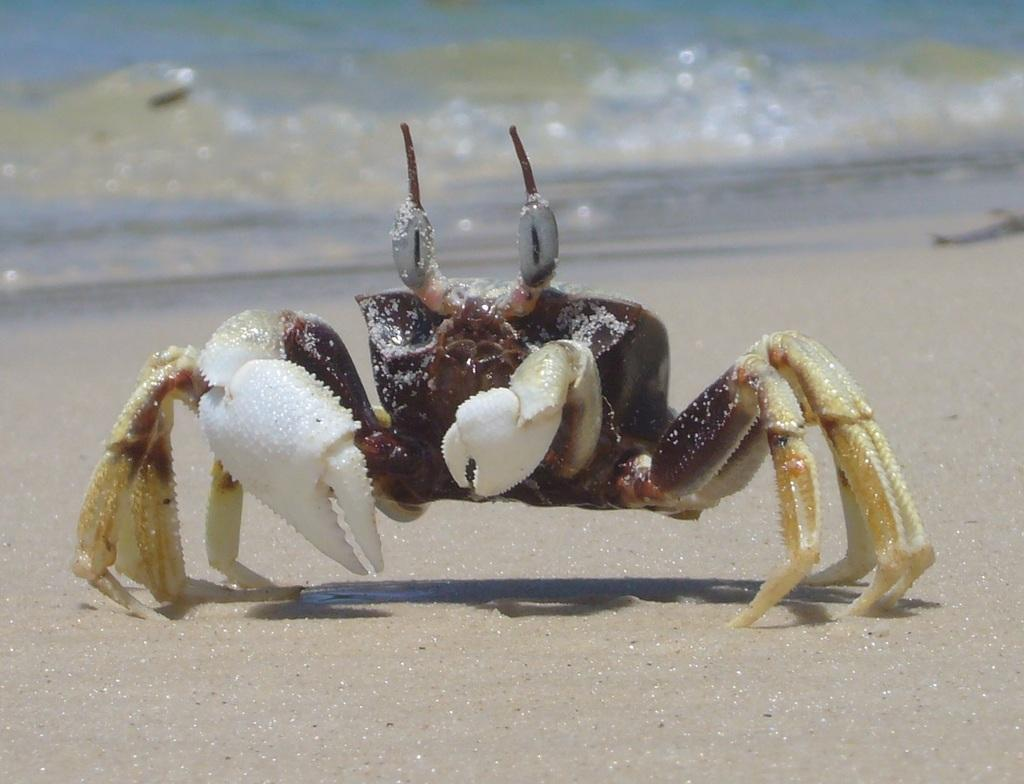What is the main subject of the image? There is a crab at the center of the image. What can be seen in the background of the image? There is a river in the background of the image. How many trees are visible in the image? There are no trees visible in the image; it features a crab at the center and a river in the background. Are there any sisters present in the image? There is no mention of sisters in the image; it features a crab and a river. 